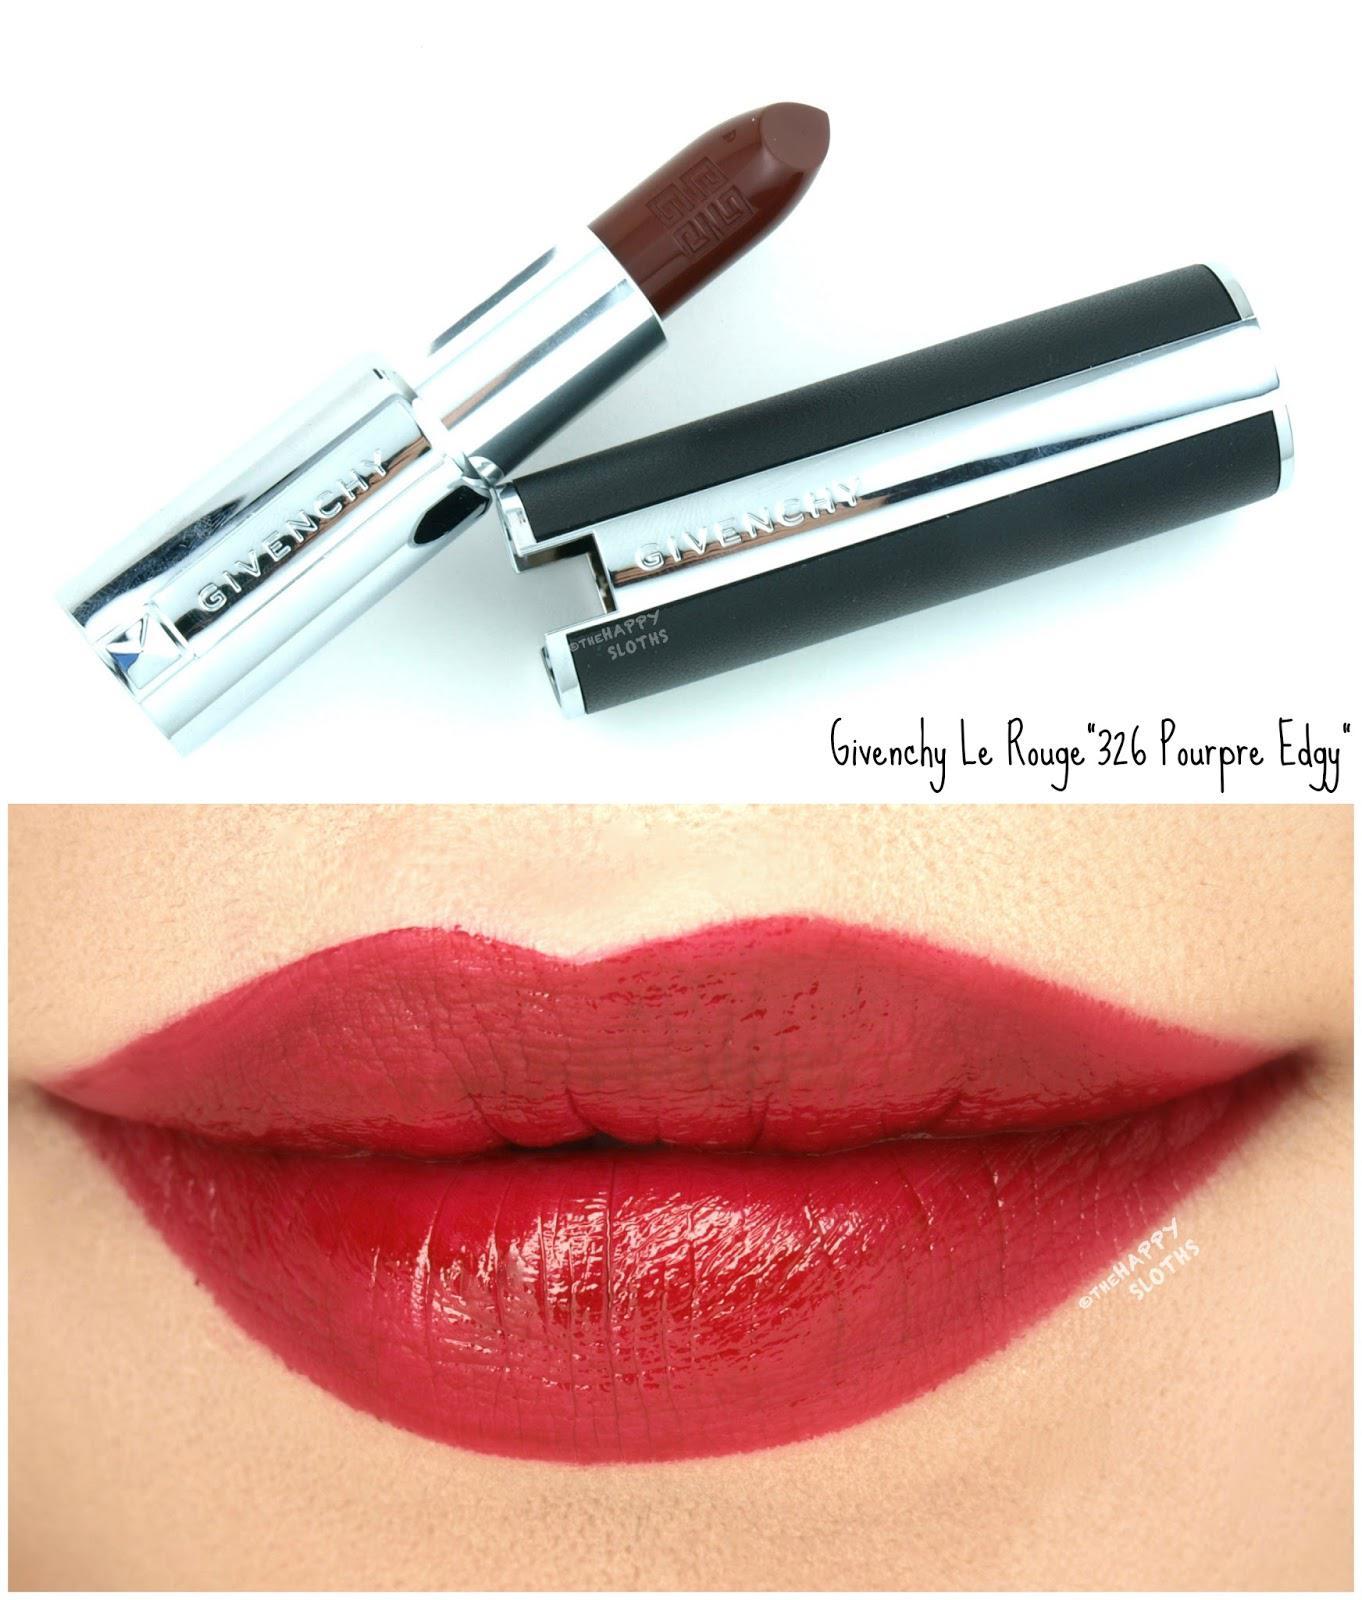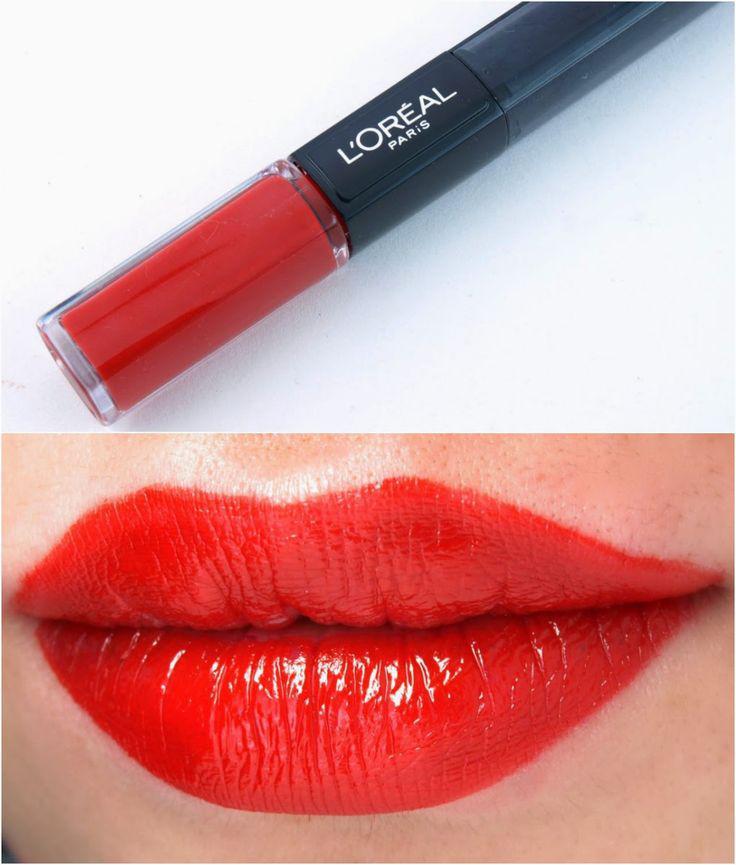The first image is the image on the left, the second image is the image on the right. Assess this claim about the two images: "The left image contains a lidded slender lip makeup over a pair of lips, while the right image shows an uncapped tube lipstick over a pair of lips.". Correct or not? Answer yes or no. No. The first image is the image on the left, the second image is the image on the right. Examine the images to the left and right. Is the description "The lip stick in the right image is uncapped." accurate? Answer yes or no. No. 